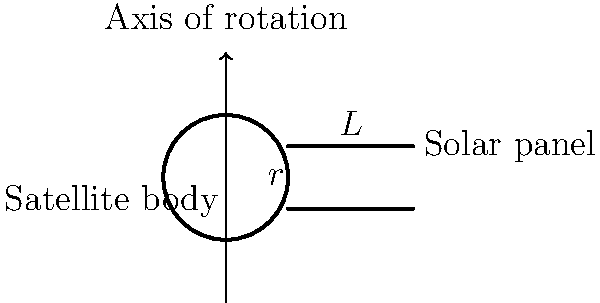A satellite with a cylindrical body (radius $r$, mass $M$) has two extended rectangular solar panels (length $L$, width $w$, mass $m$ each) attached symmetrically. The satellite rotates about its central axis. Given that the moment of inertia of a cylinder about its central axis is $\frac{1}{2}Mr^2$ and that of a thin rod about its end is $\frac{1}{3}mL^2$, what is the total moment of inertia of the satellite system? To find the total moment of inertia, we need to sum the contributions from the satellite body and the solar panels:

1. Moment of inertia of the satellite body:
   $$I_{body} = \frac{1}{2}Mr^2$$

2. Moment of inertia of each solar panel:
   - We treat each panel as a thin rod rotating about its end.
   - The panel's center of mass is at a distance of $r + \frac{L}{2}$ from the axis of rotation.
   - We use the parallel axis theorem: $I = I_{cm} + md^2$
   $$I_{panel} = \frac{1}{3}mL^2 + m(r + \frac{L}{2})^2$$

3. Total moment of inertia for both panels:
   $$I_{panels} = 2 \cdot [\frac{1}{3}mL^2 + m(r + \frac{L}{2})^2]$$

4. Total moment of inertia of the system:
   $$I_{total} = I_{body} + I_{panels}$$
   $$I_{total} = \frac{1}{2}Mr^2 + 2 \cdot [\frac{1}{3}mL^2 + m(r + \frac{L}{2})^2]$$

5. Simplify:
   $$I_{total} = \frac{1}{2}Mr^2 + \frac{2}{3}mL^2 + 2m(r + \frac{L}{2})^2$$

This is the final expression for the total moment of inertia of the satellite system.
Answer: $\frac{1}{2}Mr^2 + \frac{2}{3}mL^2 + 2m(r + \frac{L}{2})^2$ 